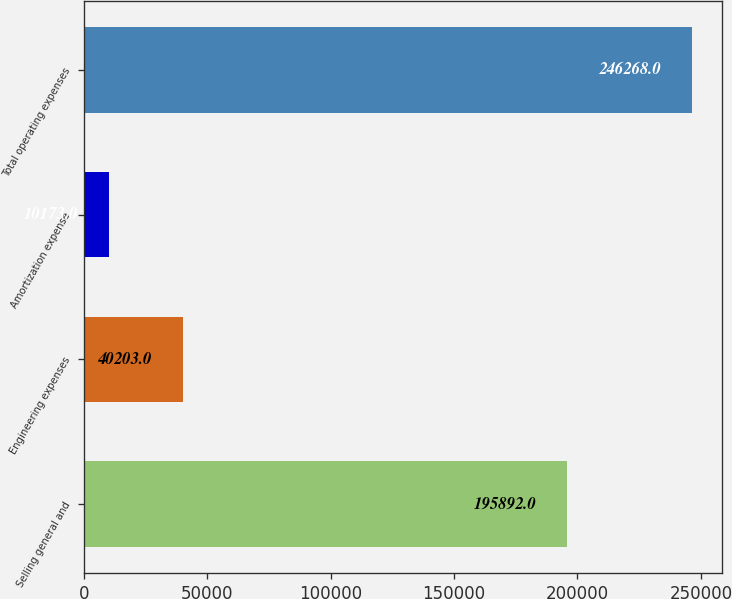Convert chart to OTSL. <chart><loc_0><loc_0><loc_500><loc_500><bar_chart><fcel>Selling general and<fcel>Engineering expenses<fcel>Amortization expense<fcel>Total operating expenses<nl><fcel>195892<fcel>40203<fcel>10173<fcel>246268<nl></chart> 